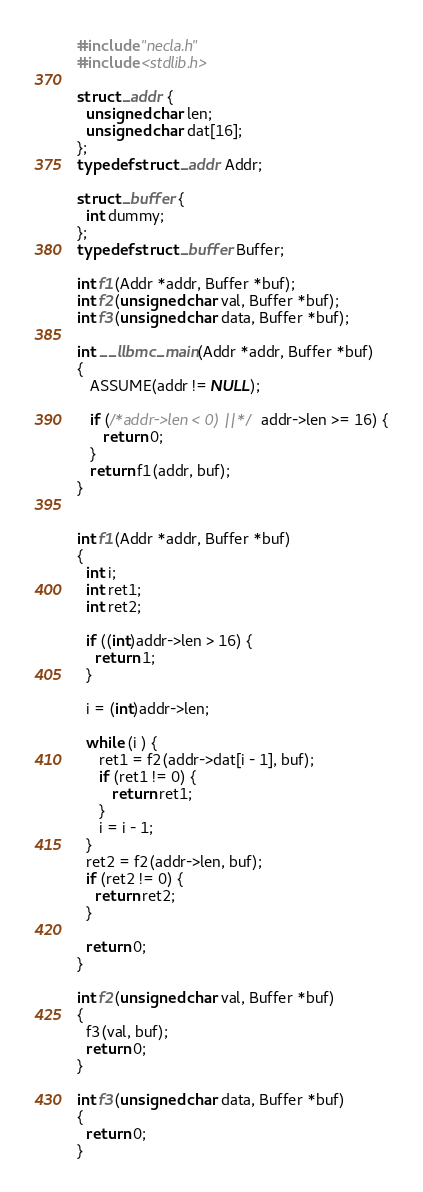<code> <loc_0><loc_0><loc_500><loc_500><_C_>#include "necla.h"
#include <stdlib.h>

struct _addr {
  unsigned char len;
  unsigned char dat[16];
};
typedef struct _addr Addr;

struct _buffer {
  int dummy;
};
typedef struct _buffer Buffer;

int f1(Addr *addr, Buffer *buf);
int f2(unsigned char val, Buffer *buf);
int f3(unsigned char data, Buffer *buf);

int __llbmc_main(Addr *addr, Buffer *buf)
{
   ASSUME(addr != NULL);
   
   if (/*addr->len < 0) ||*/ addr->len >= 16) {
      return 0;
   }
   return f1(addr, buf);
}


int f1(Addr *addr, Buffer *buf) 
{
  int i;
  int ret1;
  int ret2;
  
  if ((int)addr->len > 16) {
    return 1;
  }

  i = (int)addr->len;
  
  while (i ) {
     ret1 = f2(addr->dat[i - 1], buf);
     if (ret1 != 0) {
        return ret1;
     }
     i = i - 1;
  }
  ret2 = f2(addr->len, buf);
  if (ret2 != 0) {
    return ret2;
  }
  
  return 0;
}

int f2(unsigned char val, Buffer *buf) 
{ 
  f3(val, buf);
  return 0;
}

int f3(unsigned char data, Buffer *buf) 
{ 
  return 0;
}

</code> 